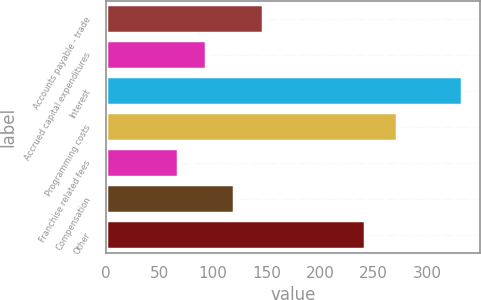<chart> <loc_0><loc_0><loc_500><loc_500><bar_chart><fcel>Accounts payable - trade<fcel>Accrued capital expenditures<fcel>Interest<fcel>Programming costs<fcel>Franchise related fees<fcel>Compensation<fcel>Other<nl><fcel>146.8<fcel>93.6<fcel>333<fcel>272<fcel>67<fcel>120.2<fcel>242<nl></chart> 